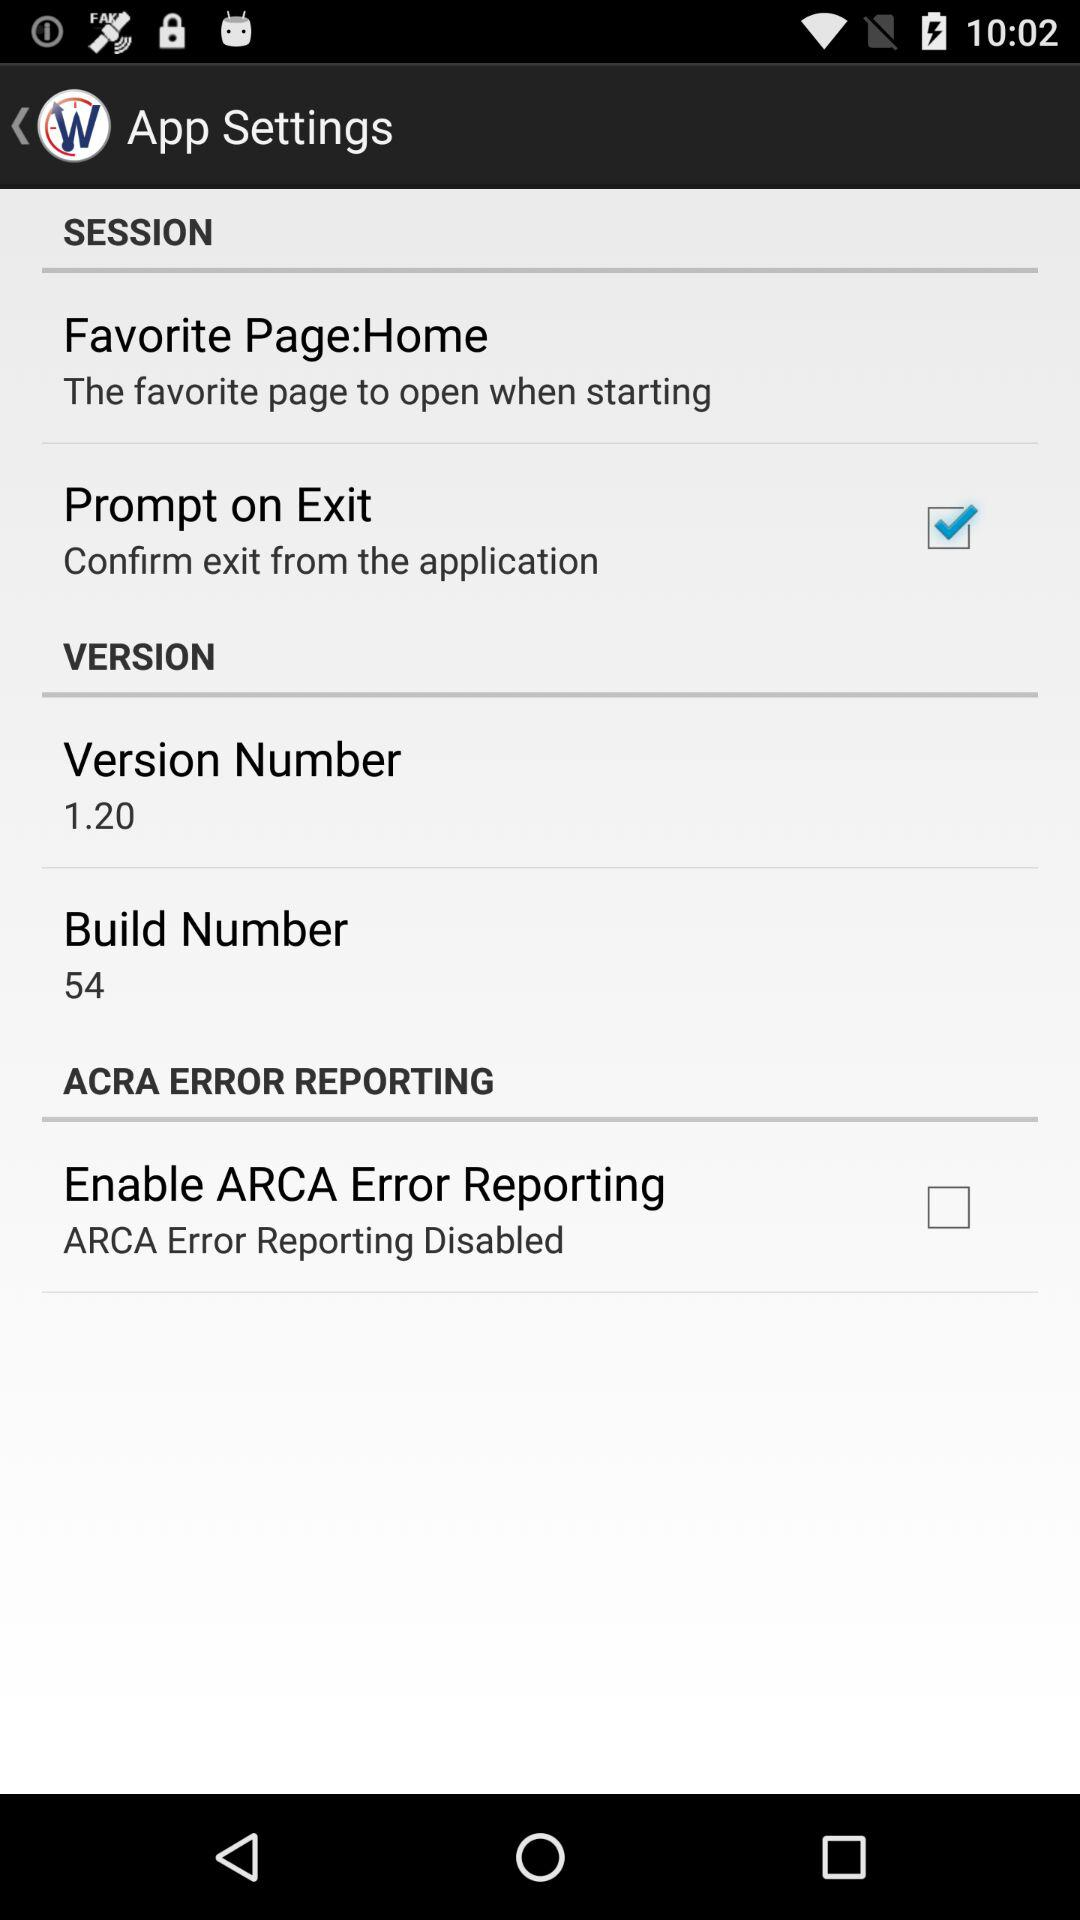What is the build number shown on the screen? The build number shown on the screen is 54. 